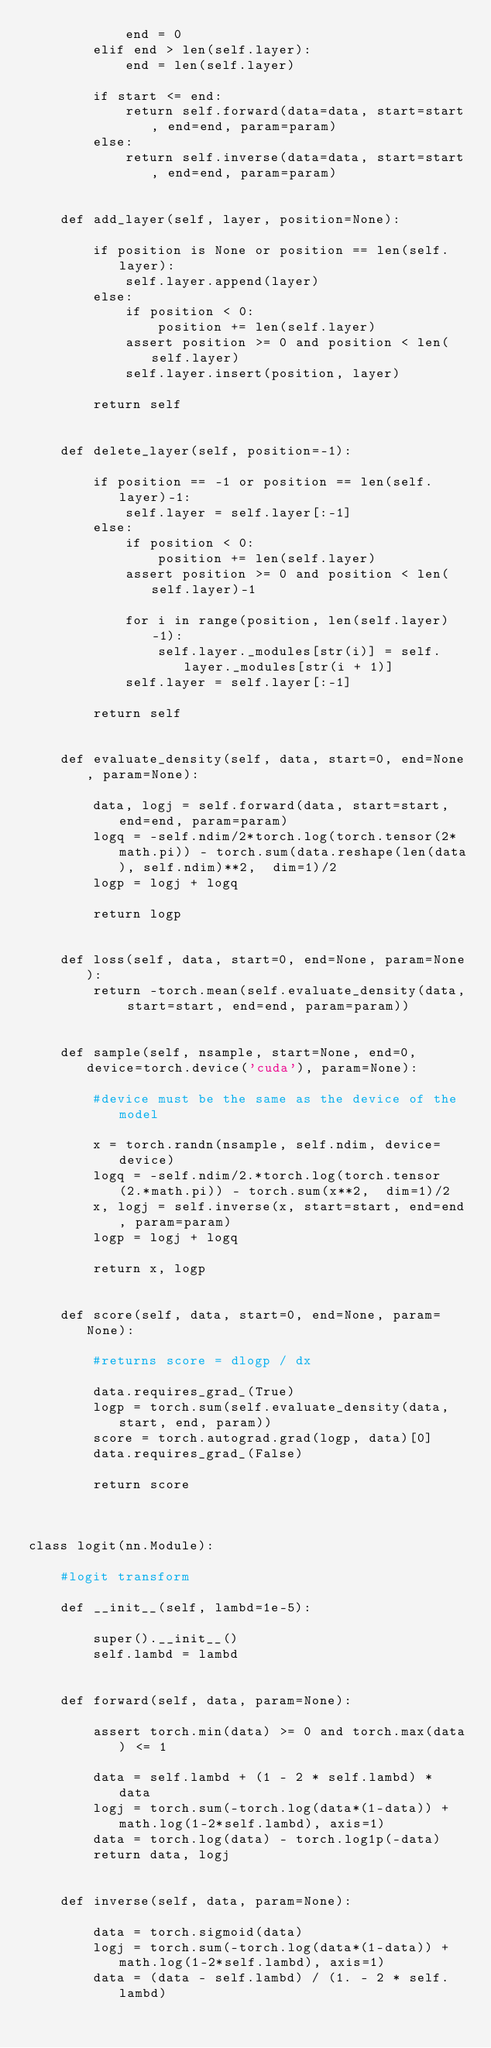Convert code to text. <code><loc_0><loc_0><loc_500><loc_500><_Python_>            end = 0
        elif end > len(self.layer):
            end = len(self.layer)

        if start <= end:
            return self.forward(data=data, start=start, end=end, param=param) 
        else:
            return self.inverse(data=data, start=start, end=end, param=param) 
    
    
    def add_layer(self, layer, position=None):
        
        if position is None or position == len(self.layer):
            self.layer.append(layer)
        else:
            if position < 0:
                position += len(self.layer)
            assert position >= 0 and position < len(self.layer)
            self.layer.insert(position, layer)
        
        return self
    
    
    def delete_layer(self, position=-1):
        
        if position == -1 or position == len(self.layer)-1:
            self.layer = self.layer[:-1]
        else:
            if position < 0:
                position += len(self.layer)
            assert position >= 0 and position < len(self.layer)-1
            
            for i in range(position, len(self.layer)-1):
                self.layer._modules[str(i)] = self.layer._modules[str(i + 1)]
            self.layer = self.layer[:-1]
        
        return self
    
    
    def evaluate_density(self, data, start=0, end=None, param=None):
        
        data, logj = self.forward(data, start=start, end=end, param=param)
        logq = -self.ndim/2*torch.log(torch.tensor(2*math.pi)) - torch.sum(data.reshape(len(data), self.ndim)**2,  dim=1)/2
        logp = logj + logq
        
        return logp


    def loss(self, data, start=0, end=None, param=None):
        return -torch.mean(self.evaluate_density(data, start=start, end=end, param=param))
    
    
    def sample(self, nsample, start=None, end=0, device=torch.device('cuda'), param=None):

        #device must be the same as the device of the model
        
        x = torch.randn(nsample, self.ndim, device=device)
        logq = -self.ndim/2.*torch.log(torch.tensor(2.*math.pi)) - torch.sum(x**2,  dim=1)/2
        x, logj = self.inverse(x, start=start, end=end, param=param)
        logp = logj + logq

        return x, logp


    def score(self, data, start=0, end=None, param=None):

        #returns score = dlogp / dx

        data.requires_grad_(True)
        logp = torch.sum(self.evaluate_density(data, start, end, param))
        score = torch.autograd.grad(logp, data)[0]
        data.requires_grad_(False)

        return score



class logit(nn.Module):

    #logit transform

    def __init__(self, lambd=1e-5):

        super().__init__()
        self.lambd = lambd


    def forward(self, data, param=None):

        assert torch.min(data) >= 0 and torch.max(data) <= 1

        data = self.lambd + (1 - 2 * self.lambd) * data 
        logj = torch.sum(-torch.log(data*(1-data)) + math.log(1-2*self.lambd), axis=1)
        data = torch.log(data) - torch.log1p(-data)
        return data, logj


    def inverse(self, data, param=None):

        data = torch.sigmoid(data) 
        logj = torch.sum(-torch.log(data*(1-data)) + math.log(1-2*self.lambd), axis=1)
        data = (data - self.lambd) / (1. - 2 * self.lambd) </code> 